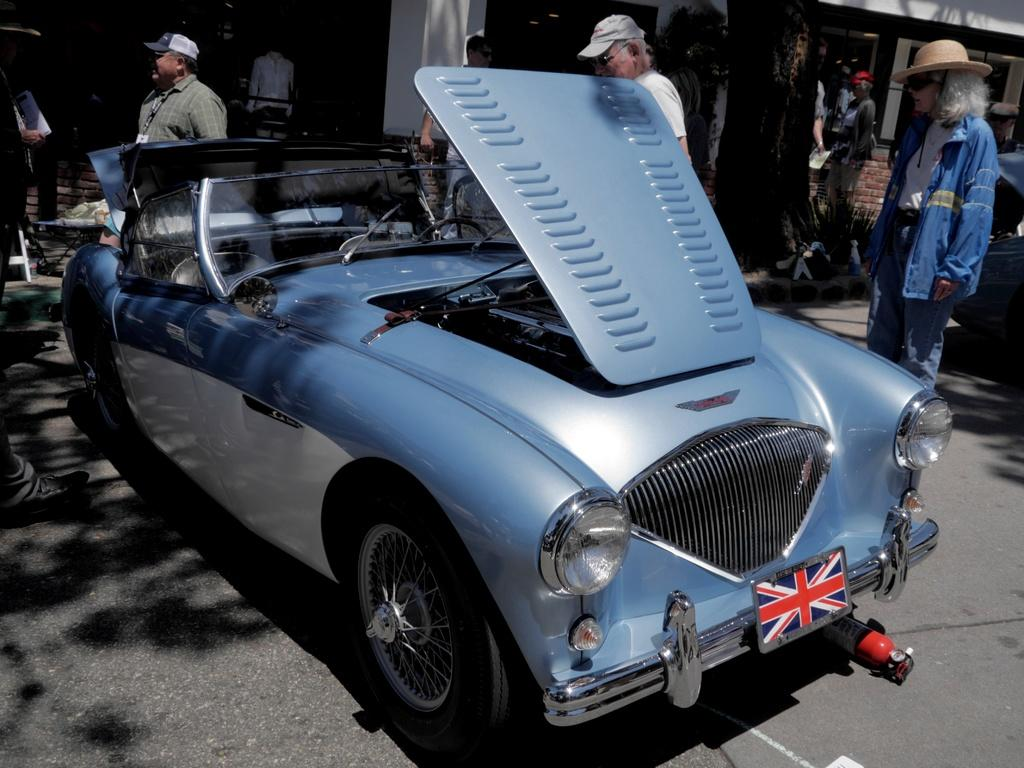What is the condition of the car in the image? The car has an open hood in the image. Where is the car located? The car is on the road. What is happening around the car on the road? People are walking on either side of the car on the road. What can be seen in the background of the image? There is a building behind the car. What type of insect is flying around the car in the image? There is no insect flying around the car in the image. How many robins can be seen perched on the car in the image? There are no robins present in the image. 